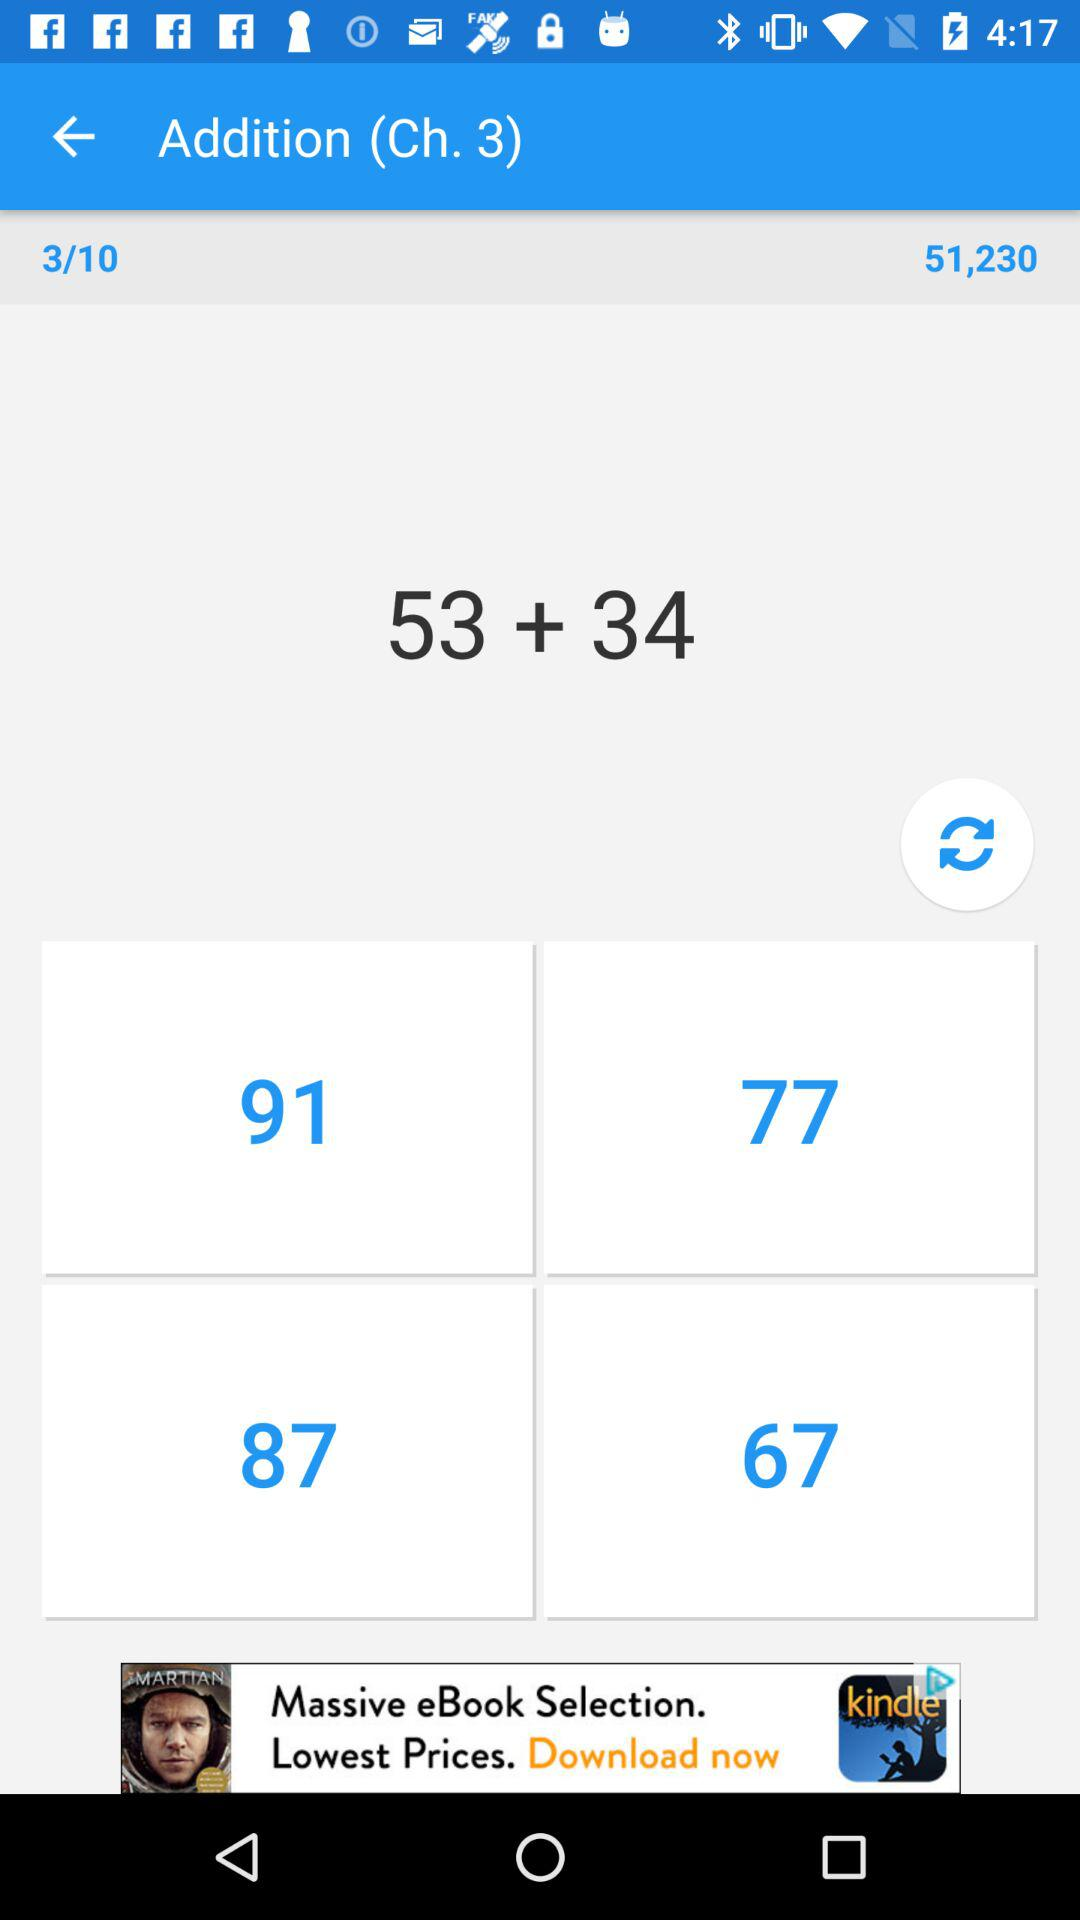What is the total of the two numbers?
Answer the question using a single word or phrase. 87 